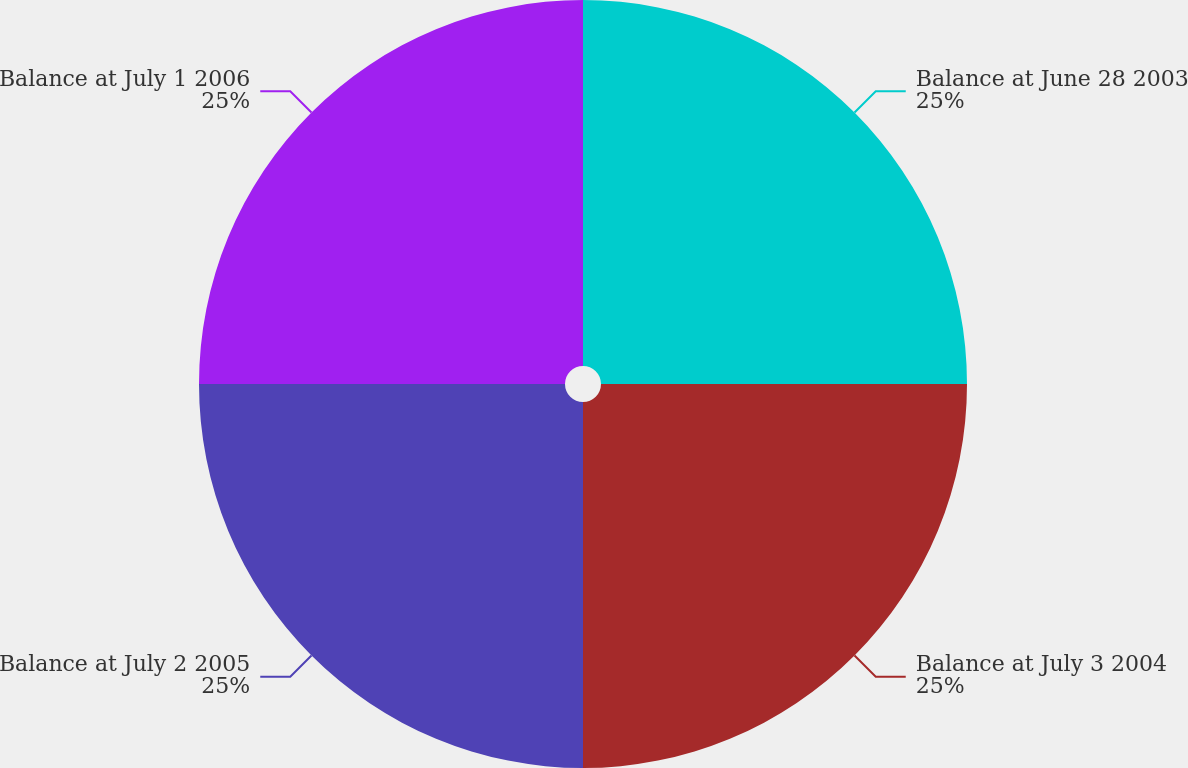Convert chart. <chart><loc_0><loc_0><loc_500><loc_500><pie_chart><fcel>Balance at June 28 2003<fcel>Balance at July 3 2004<fcel>Balance at July 2 2005<fcel>Balance at July 1 2006<nl><fcel>25.0%<fcel>25.0%<fcel>25.0%<fcel>25.0%<nl></chart> 